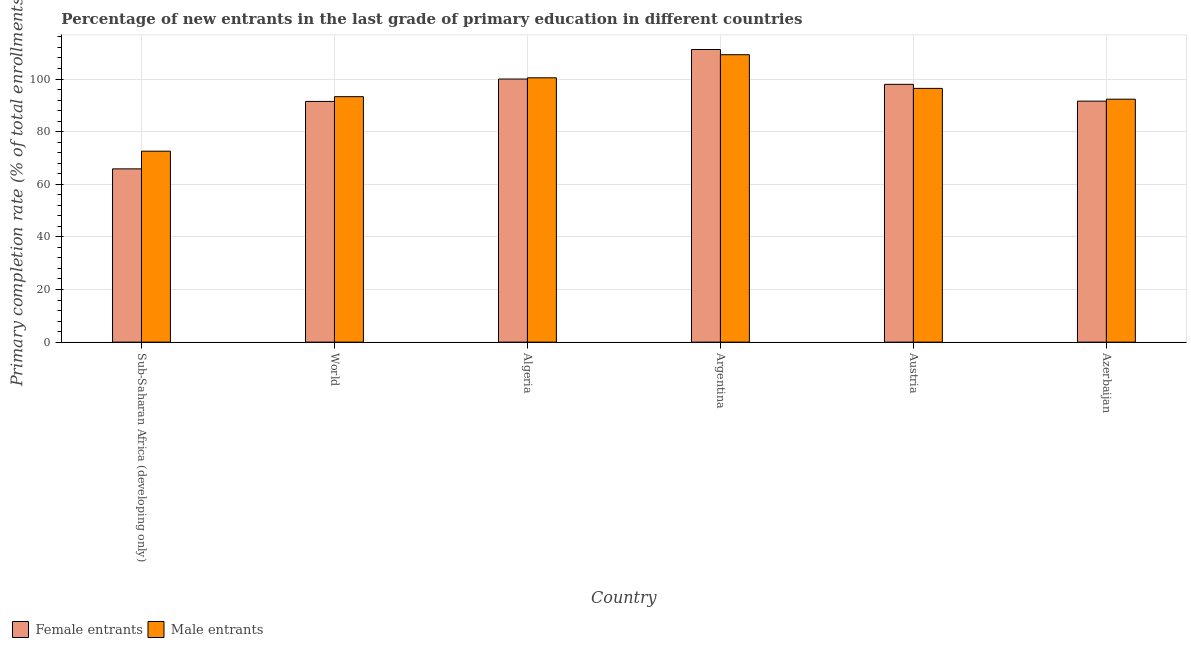How many groups of bars are there?
Give a very brief answer. 6. Are the number of bars per tick equal to the number of legend labels?
Offer a very short reply. Yes. How many bars are there on the 5th tick from the right?
Provide a short and direct response. 2. What is the label of the 2nd group of bars from the left?
Your answer should be very brief. World. In how many cases, is the number of bars for a given country not equal to the number of legend labels?
Keep it short and to the point. 0. What is the primary completion rate of male entrants in Argentina?
Make the answer very short. 109.24. Across all countries, what is the maximum primary completion rate of male entrants?
Offer a very short reply. 109.24. Across all countries, what is the minimum primary completion rate of male entrants?
Provide a succinct answer. 72.57. In which country was the primary completion rate of male entrants maximum?
Give a very brief answer. Argentina. In which country was the primary completion rate of female entrants minimum?
Your response must be concise. Sub-Saharan Africa (developing only). What is the total primary completion rate of male entrants in the graph?
Give a very brief answer. 564.35. What is the difference between the primary completion rate of female entrants in Azerbaijan and that in Sub-Saharan Africa (developing only)?
Provide a succinct answer. 25.74. What is the difference between the primary completion rate of male entrants in Sub-Saharan Africa (developing only) and the primary completion rate of female entrants in World?
Provide a short and direct response. -18.91. What is the average primary completion rate of female entrants per country?
Give a very brief answer. 93.02. What is the difference between the primary completion rate of female entrants and primary completion rate of male entrants in World?
Your answer should be compact. -1.8. What is the ratio of the primary completion rate of male entrants in Algeria to that in Sub-Saharan Africa (developing only)?
Make the answer very short. 1.38. What is the difference between the highest and the second highest primary completion rate of female entrants?
Ensure brevity in your answer.  11.22. What is the difference between the highest and the lowest primary completion rate of male entrants?
Your answer should be very brief. 36.66. In how many countries, is the primary completion rate of female entrants greater than the average primary completion rate of female entrants taken over all countries?
Your response must be concise. 3. What does the 2nd bar from the left in Sub-Saharan Africa (developing only) represents?
Provide a succinct answer. Male entrants. What does the 2nd bar from the right in Azerbaijan represents?
Keep it short and to the point. Female entrants. What is the difference between two consecutive major ticks on the Y-axis?
Offer a very short reply. 20. Does the graph contain any zero values?
Provide a short and direct response. No. Does the graph contain grids?
Your answer should be compact. Yes. Where does the legend appear in the graph?
Make the answer very short. Bottom left. How are the legend labels stacked?
Your answer should be very brief. Horizontal. What is the title of the graph?
Keep it short and to the point. Percentage of new entrants in the last grade of primary education in different countries. What is the label or title of the X-axis?
Offer a very short reply. Country. What is the label or title of the Y-axis?
Keep it short and to the point. Primary completion rate (% of total enrollments). What is the Primary completion rate (% of total enrollments) in Female entrants in Sub-Saharan Africa (developing only)?
Provide a succinct answer. 65.85. What is the Primary completion rate (% of total enrollments) of Male entrants in Sub-Saharan Africa (developing only)?
Offer a terse response. 72.57. What is the Primary completion rate (% of total enrollments) in Female entrants in World?
Provide a short and direct response. 91.49. What is the Primary completion rate (% of total enrollments) of Male entrants in World?
Give a very brief answer. 93.29. What is the Primary completion rate (% of total enrollments) of Female entrants in Algeria?
Your answer should be compact. 100. What is the Primary completion rate (% of total enrollments) of Male entrants in Algeria?
Your response must be concise. 100.46. What is the Primary completion rate (% of total enrollments) in Female entrants in Argentina?
Your response must be concise. 111.22. What is the Primary completion rate (% of total enrollments) in Male entrants in Argentina?
Offer a very short reply. 109.24. What is the Primary completion rate (% of total enrollments) in Female entrants in Austria?
Make the answer very short. 97.98. What is the Primary completion rate (% of total enrollments) of Male entrants in Austria?
Your response must be concise. 96.44. What is the Primary completion rate (% of total enrollments) in Female entrants in Azerbaijan?
Ensure brevity in your answer.  91.59. What is the Primary completion rate (% of total enrollments) of Male entrants in Azerbaijan?
Ensure brevity in your answer.  92.34. Across all countries, what is the maximum Primary completion rate (% of total enrollments) in Female entrants?
Keep it short and to the point. 111.22. Across all countries, what is the maximum Primary completion rate (% of total enrollments) in Male entrants?
Your response must be concise. 109.24. Across all countries, what is the minimum Primary completion rate (% of total enrollments) of Female entrants?
Your answer should be very brief. 65.85. Across all countries, what is the minimum Primary completion rate (% of total enrollments) in Male entrants?
Give a very brief answer. 72.57. What is the total Primary completion rate (% of total enrollments) of Female entrants in the graph?
Give a very brief answer. 558.13. What is the total Primary completion rate (% of total enrollments) of Male entrants in the graph?
Provide a succinct answer. 564.35. What is the difference between the Primary completion rate (% of total enrollments) of Female entrants in Sub-Saharan Africa (developing only) and that in World?
Keep it short and to the point. -25.64. What is the difference between the Primary completion rate (% of total enrollments) of Male entrants in Sub-Saharan Africa (developing only) and that in World?
Your answer should be compact. -20.72. What is the difference between the Primary completion rate (% of total enrollments) of Female entrants in Sub-Saharan Africa (developing only) and that in Algeria?
Ensure brevity in your answer.  -34.15. What is the difference between the Primary completion rate (% of total enrollments) of Male entrants in Sub-Saharan Africa (developing only) and that in Algeria?
Make the answer very short. -27.89. What is the difference between the Primary completion rate (% of total enrollments) in Female entrants in Sub-Saharan Africa (developing only) and that in Argentina?
Make the answer very short. -45.36. What is the difference between the Primary completion rate (% of total enrollments) in Male entrants in Sub-Saharan Africa (developing only) and that in Argentina?
Provide a succinct answer. -36.66. What is the difference between the Primary completion rate (% of total enrollments) in Female entrants in Sub-Saharan Africa (developing only) and that in Austria?
Keep it short and to the point. -32.13. What is the difference between the Primary completion rate (% of total enrollments) of Male entrants in Sub-Saharan Africa (developing only) and that in Austria?
Your response must be concise. -23.87. What is the difference between the Primary completion rate (% of total enrollments) in Female entrants in Sub-Saharan Africa (developing only) and that in Azerbaijan?
Make the answer very short. -25.74. What is the difference between the Primary completion rate (% of total enrollments) of Male entrants in Sub-Saharan Africa (developing only) and that in Azerbaijan?
Give a very brief answer. -19.76. What is the difference between the Primary completion rate (% of total enrollments) of Female entrants in World and that in Algeria?
Your answer should be compact. -8.51. What is the difference between the Primary completion rate (% of total enrollments) of Male entrants in World and that in Algeria?
Provide a short and direct response. -7.17. What is the difference between the Primary completion rate (% of total enrollments) of Female entrants in World and that in Argentina?
Give a very brief answer. -19.73. What is the difference between the Primary completion rate (% of total enrollments) in Male entrants in World and that in Argentina?
Offer a terse response. -15.95. What is the difference between the Primary completion rate (% of total enrollments) in Female entrants in World and that in Austria?
Keep it short and to the point. -6.49. What is the difference between the Primary completion rate (% of total enrollments) of Male entrants in World and that in Austria?
Offer a very short reply. -3.15. What is the difference between the Primary completion rate (% of total enrollments) of Female entrants in World and that in Azerbaijan?
Make the answer very short. -0.1. What is the difference between the Primary completion rate (% of total enrollments) of Female entrants in Algeria and that in Argentina?
Offer a terse response. -11.22. What is the difference between the Primary completion rate (% of total enrollments) of Male entrants in Algeria and that in Argentina?
Give a very brief answer. -8.78. What is the difference between the Primary completion rate (% of total enrollments) of Female entrants in Algeria and that in Austria?
Ensure brevity in your answer.  2.02. What is the difference between the Primary completion rate (% of total enrollments) of Male entrants in Algeria and that in Austria?
Give a very brief answer. 4.02. What is the difference between the Primary completion rate (% of total enrollments) in Female entrants in Algeria and that in Azerbaijan?
Your answer should be very brief. 8.41. What is the difference between the Primary completion rate (% of total enrollments) in Male entrants in Algeria and that in Azerbaijan?
Your response must be concise. 8.12. What is the difference between the Primary completion rate (% of total enrollments) in Female entrants in Argentina and that in Austria?
Ensure brevity in your answer.  13.24. What is the difference between the Primary completion rate (% of total enrollments) of Male entrants in Argentina and that in Austria?
Your response must be concise. 12.8. What is the difference between the Primary completion rate (% of total enrollments) in Female entrants in Argentina and that in Azerbaijan?
Your answer should be compact. 19.62. What is the difference between the Primary completion rate (% of total enrollments) of Male entrants in Argentina and that in Azerbaijan?
Make the answer very short. 16.9. What is the difference between the Primary completion rate (% of total enrollments) of Female entrants in Austria and that in Azerbaijan?
Give a very brief answer. 6.38. What is the difference between the Primary completion rate (% of total enrollments) of Male entrants in Austria and that in Azerbaijan?
Offer a very short reply. 4.1. What is the difference between the Primary completion rate (% of total enrollments) of Female entrants in Sub-Saharan Africa (developing only) and the Primary completion rate (% of total enrollments) of Male entrants in World?
Offer a terse response. -27.44. What is the difference between the Primary completion rate (% of total enrollments) of Female entrants in Sub-Saharan Africa (developing only) and the Primary completion rate (% of total enrollments) of Male entrants in Algeria?
Give a very brief answer. -34.61. What is the difference between the Primary completion rate (% of total enrollments) of Female entrants in Sub-Saharan Africa (developing only) and the Primary completion rate (% of total enrollments) of Male entrants in Argentina?
Your answer should be very brief. -43.39. What is the difference between the Primary completion rate (% of total enrollments) in Female entrants in Sub-Saharan Africa (developing only) and the Primary completion rate (% of total enrollments) in Male entrants in Austria?
Ensure brevity in your answer.  -30.59. What is the difference between the Primary completion rate (% of total enrollments) of Female entrants in Sub-Saharan Africa (developing only) and the Primary completion rate (% of total enrollments) of Male entrants in Azerbaijan?
Your answer should be compact. -26.49. What is the difference between the Primary completion rate (% of total enrollments) of Female entrants in World and the Primary completion rate (% of total enrollments) of Male entrants in Algeria?
Make the answer very short. -8.97. What is the difference between the Primary completion rate (% of total enrollments) of Female entrants in World and the Primary completion rate (% of total enrollments) of Male entrants in Argentina?
Ensure brevity in your answer.  -17.75. What is the difference between the Primary completion rate (% of total enrollments) of Female entrants in World and the Primary completion rate (% of total enrollments) of Male entrants in Austria?
Provide a succinct answer. -4.95. What is the difference between the Primary completion rate (% of total enrollments) of Female entrants in World and the Primary completion rate (% of total enrollments) of Male entrants in Azerbaijan?
Your answer should be very brief. -0.85. What is the difference between the Primary completion rate (% of total enrollments) of Female entrants in Algeria and the Primary completion rate (% of total enrollments) of Male entrants in Argentina?
Give a very brief answer. -9.24. What is the difference between the Primary completion rate (% of total enrollments) in Female entrants in Algeria and the Primary completion rate (% of total enrollments) in Male entrants in Austria?
Keep it short and to the point. 3.56. What is the difference between the Primary completion rate (% of total enrollments) of Female entrants in Algeria and the Primary completion rate (% of total enrollments) of Male entrants in Azerbaijan?
Your response must be concise. 7.66. What is the difference between the Primary completion rate (% of total enrollments) in Female entrants in Argentina and the Primary completion rate (% of total enrollments) in Male entrants in Austria?
Your response must be concise. 14.77. What is the difference between the Primary completion rate (% of total enrollments) of Female entrants in Argentina and the Primary completion rate (% of total enrollments) of Male entrants in Azerbaijan?
Give a very brief answer. 18.88. What is the difference between the Primary completion rate (% of total enrollments) of Female entrants in Austria and the Primary completion rate (% of total enrollments) of Male entrants in Azerbaijan?
Provide a short and direct response. 5.64. What is the average Primary completion rate (% of total enrollments) of Female entrants per country?
Make the answer very short. 93.02. What is the average Primary completion rate (% of total enrollments) of Male entrants per country?
Give a very brief answer. 94.06. What is the difference between the Primary completion rate (% of total enrollments) of Female entrants and Primary completion rate (% of total enrollments) of Male entrants in Sub-Saharan Africa (developing only)?
Offer a terse response. -6.72. What is the difference between the Primary completion rate (% of total enrollments) of Female entrants and Primary completion rate (% of total enrollments) of Male entrants in World?
Offer a very short reply. -1.8. What is the difference between the Primary completion rate (% of total enrollments) of Female entrants and Primary completion rate (% of total enrollments) of Male entrants in Algeria?
Ensure brevity in your answer.  -0.46. What is the difference between the Primary completion rate (% of total enrollments) of Female entrants and Primary completion rate (% of total enrollments) of Male entrants in Argentina?
Give a very brief answer. 1.98. What is the difference between the Primary completion rate (% of total enrollments) in Female entrants and Primary completion rate (% of total enrollments) in Male entrants in Austria?
Provide a short and direct response. 1.54. What is the difference between the Primary completion rate (% of total enrollments) of Female entrants and Primary completion rate (% of total enrollments) of Male entrants in Azerbaijan?
Your response must be concise. -0.74. What is the ratio of the Primary completion rate (% of total enrollments) in Female entrants in Sub-Saharan Africa (developing only) to that in World?
Keep it short and to the point. 0.72. What is the ratio of the Primary completion rate (% of total enrollments) in Male entrants in Sub-Saharan Africa (developing only) to that in World?
Your answer should be compact. 0.78. What is the ratio of the Primary completion rate (% of total enrollments) in Female entrants in Sub-Saharan Africa (developing only) to that in Algeria?
Your answer should be very brief. 0.66. What is the ratio of the Primary completion rate (% of total enrollments) in Male entrants in Sub-Saharan Africa (developing only) to that in Algeria?
Give a very brief answer. 0.72. What is the ratio of the Primary completion rate (% of total enrollments) in Female entrants in Sub-Saharan Africa (developing only) to that in Argentina?
Ensure brevity in your answer.  0.59. What is the ratio of the Primary completion rate (% of total enrollments) in Male entrants in Sub-Saharan Africa (developing only) to that in Argentina?
Offer a terse response. 0.66. What is the ratio of the Primary completion rate (% of total enrollments) of Female entrants in Sub-Saharan Africa (developing only) to that in Austria?
Provide a short and direct response. 0.67. What is the ratio of the Primary completion rate (% of total enrollments) in Male entrants in Sub-Saharan Africa (developing only) to that in Austria?
Offer a terse response. 0.75. What is the ratio of the Primary completion rate (% of total enrollments) in Female entrants in Sub-Saharan Africa (developing only) to that in Azerbaijan?
Ensure brevity in your answer.  0.72. What is the ratio of the Primary completion rate (% of total enrollments) of Male entrants in Sub-Saharan Africa (developing only) to that in Azerbaijan?
Your response must be concise. 0.79. What is the ratio of the Primary completion rate (% of total enrollments) of Female entrants in World to that in Algeria?
Your answer should be very brief. 0.91. What is the ratio of the Primary completion rate (% of total enrollments) of Female entrants in World to that in Argentina?
Give a very brief answer. 0.82. What is the ratio of the Primary completion rate (% of total enrollments) of Male entrants in World to that in Argentina?
Offer a terse response. 0.85. What is the ratio of the Primary completion rate (% of total enrollments) in Female entrants in World to that in Austria?
Ensure brevity in your answer.  0.93. What is the ratio of the Primary completion rate (% of total enrollments) in Male entrants in World to that in Austria?
Offer a terse response. 0.97. What is the ratio of the Primary completion rate (% of total enrollments) of Male entrants in World to that in Azerbaijan?
Your response must be concise. 1.01. What is the ratio of the Primary completion rate (% of total enrollments) in Female entrants in Algeria to that in Argentina?
Offer a very short reply. 0.9. What is the ratio of the Primary completion rate (% of total enrollments) of Male entrants in Algeria to that in Argentina?
Your answer should be compact. 0.92. What is the ratio of the Primary completion rate (% of total enrollments) of Female entrants in Algeria to that in Austria?
Offer a very short reply. 1.02. What is the ratio of the Primary completion rate (% of total enrollments) in Male entrants in Algeria to that in Austria?
Make the answer very short. 1.04. What is the ratio of the Primary completion rate (% of total enrollments) of Female entrants in Algeria to that in Azerbaijan?
Offer a terse response. 1.09. What is the ratio of the Primary completion rate (% of total enrollments) of Male entrants in Algeria to that in Azerbaijan?
Make the answer very short. 1.09. What is the ratio of the Primary completion rate (% of total enrollments) of Female entrants in Argentina to that in Austria?
Give a very brief answer. 1.14. What is the ratio of the Primary completion rate (% of total enrollments) of Male entrants in Argentina to that in Austria?
Make the answer very short. 1.13. What is the ratio of the Primary completion rate (% of total enrollments) of Female entrants in Argentina to that in Azerbaijan?
Offer a terse response. 1.21. What is the ratio of the Primary completion rate (% of total enrollments) in Male entrants in Argentina to that in Azerbaijan?
Offer a terse response. 1.18. What is the ratio of the Primary completion rate (% of total enrollments) of Female entrants in Austria to that in Azerbaijan?
Offer a very short reply. 1.07. What is the ratio of the Primary completion rate (% of total enrollments) of Male entrants in Austria to that in Azerbaijan?
Provide a succinct answer. 1.04. What is the difference between the highest and the second highest Primary completion rate (% of total enrollments) in Female entrants?
Make the answer very short. 11.22. What is the difference between the highest and the second highest Primary completion rate (% of total enrollments) in Male entrants?
Offer a terse response. 8.78. What is the difference between the highest and the lowest Primary completion rate (% of total enrollments) of Female entrants?
Give a very brief answer. 45.36. What is the difference between the highest and the lowest Primary completion rate (% of total enrollments) in Male entrants?
Give a very brief answer. 36.66. 